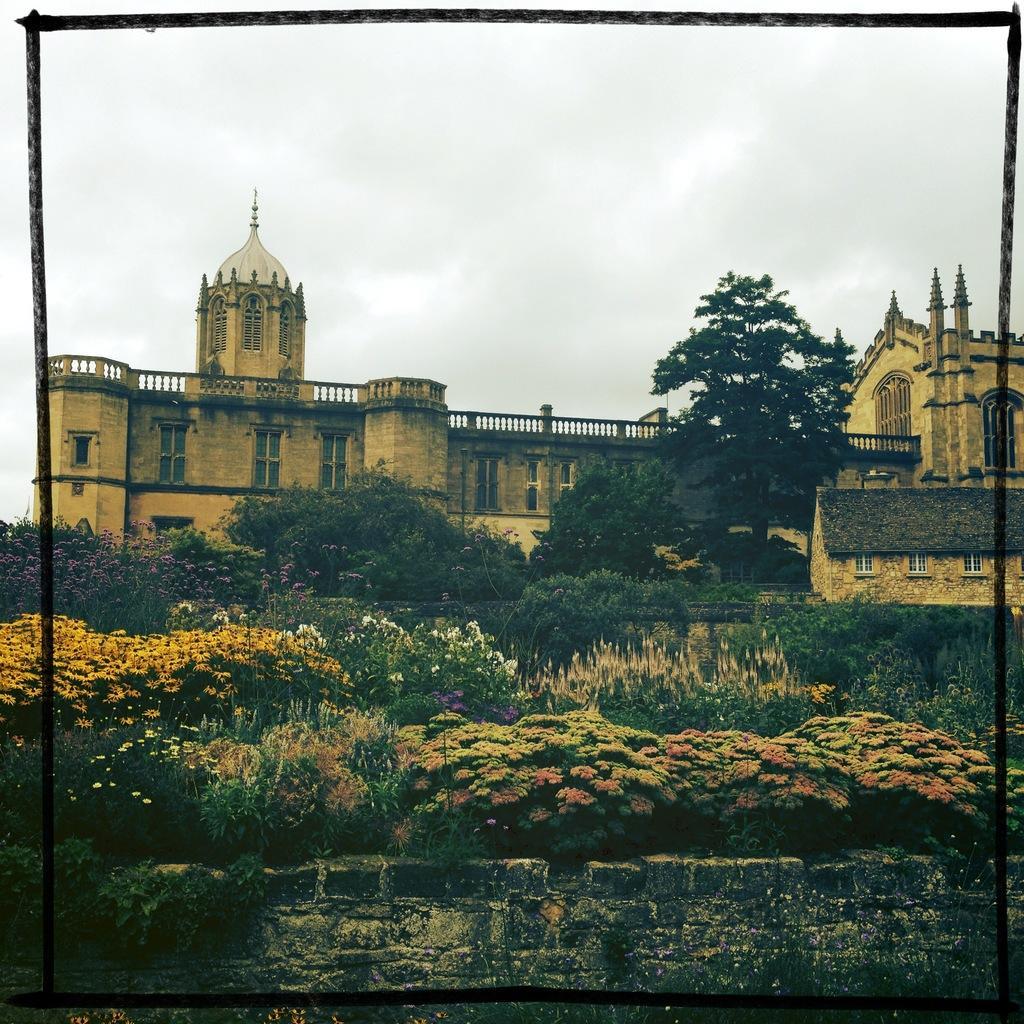How would you summarize this image in a sentence or two? In this picture we can see few buildings, trees and flowers. 